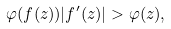<formula> <loc_0><loc_0><loc_500><loc_500>\varphi ( f ( z ) ) | f ^ { \prime } ( z ) | > \varphi ( z ) ,</formula> 